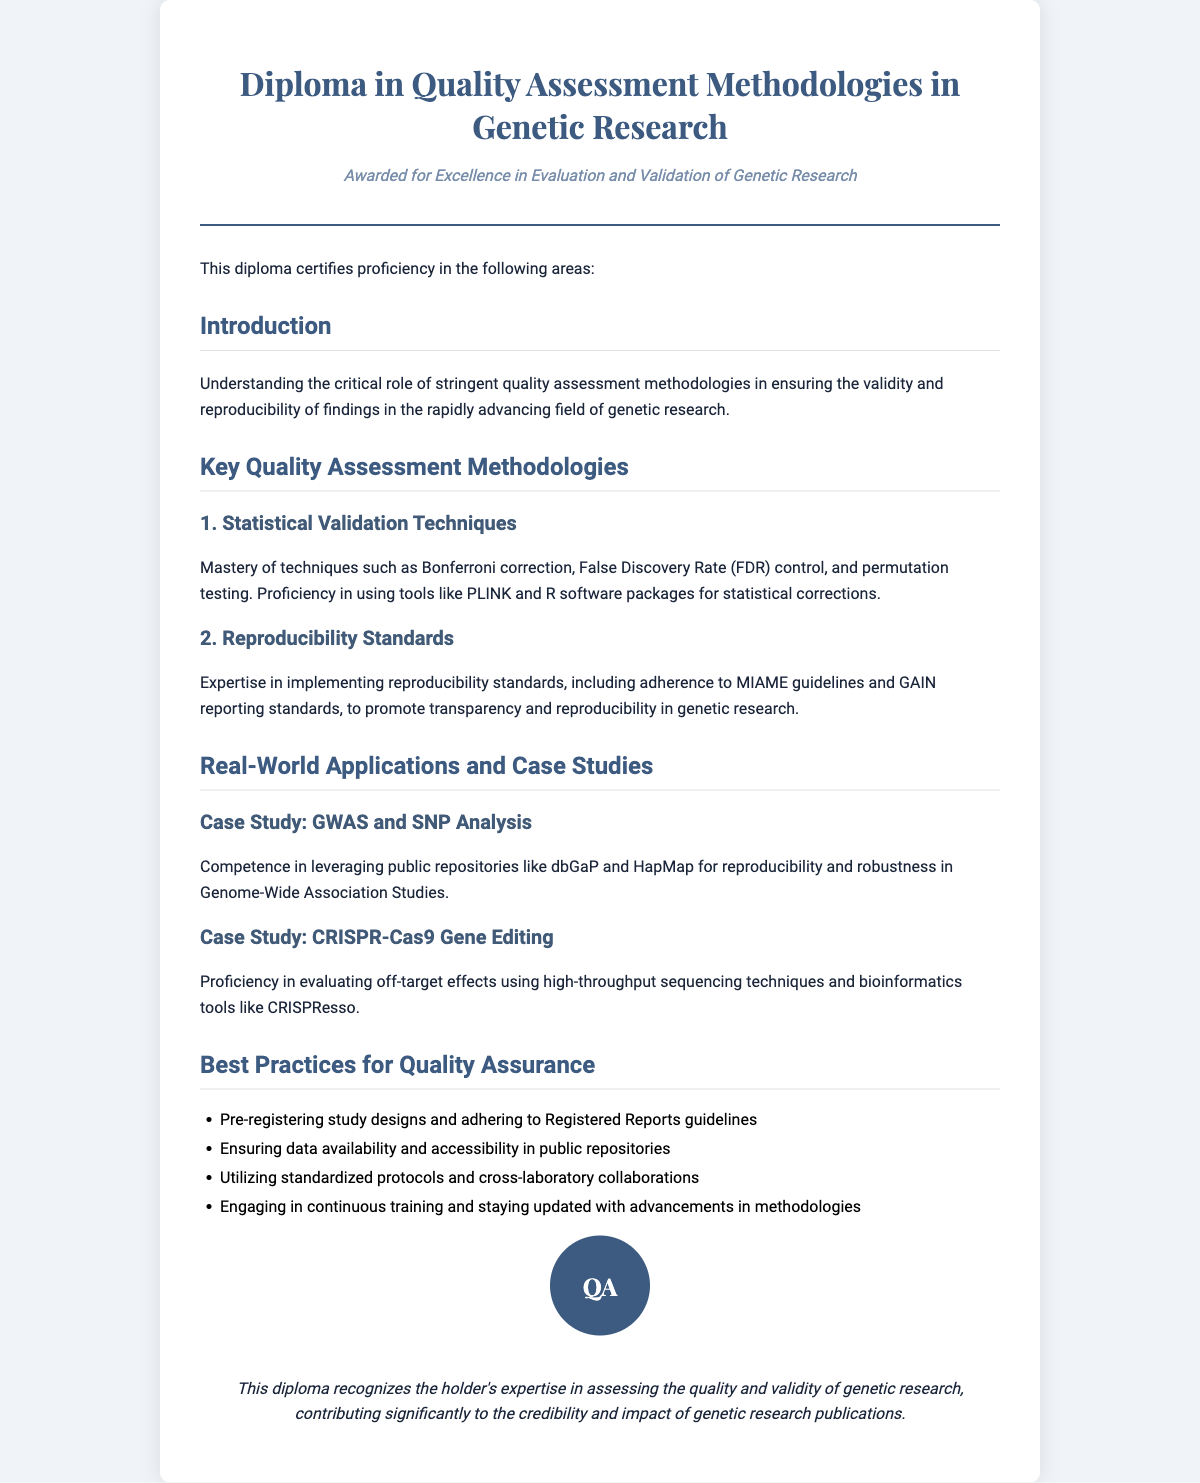what is the title of the diploma? The title of the diploma is mentioned in the header.
Answer: Diploma in Quality Assessment Methodologies in Genetic Research what is the subtitle of the diploma? The subtitle is indicated directly below the title.
Answer: Awarded for Excellence in Evaluation and Validation of Genetic Research what are the two key areas of quality assessment methodologies listed? The two main areas can be found under the "Key Quality Assessment Methodologies" section.
Answer: Statistical Validation Techniques and Reproducibility Standards which case study focuses on Genome-Wide Association Studies? The title of the case study is provided in the "Real-World Applications and Case Studies" section.
Answer: GWAS and SNP Analysis what statistical technique is mentioned for controlling false discoveries? This technique is explicitly stated under the "Statistical Validation Techniques" section.
Answer: False Discovery Rate (FDR) control what guideline is mentioned for promoting transparency in genetic research? The guideline is referenced in the "Reproducibility Standards" section.
Answer: MIAME guidelines how many best practices for quality assurance are listed? The number of practices can be counted in the "Best Practices for Quality Assurance" section.
Answer: Four what tool is mentioned for evaluating off-target effects in gene editing? The tool is stated under the case study related to CRISPR-Cas9.
Answer: CRISPResso what is the purpose of pre-registering study designs? The purpose is implied in the context of best practices for quality assurance.
Answer: Quality assurance 